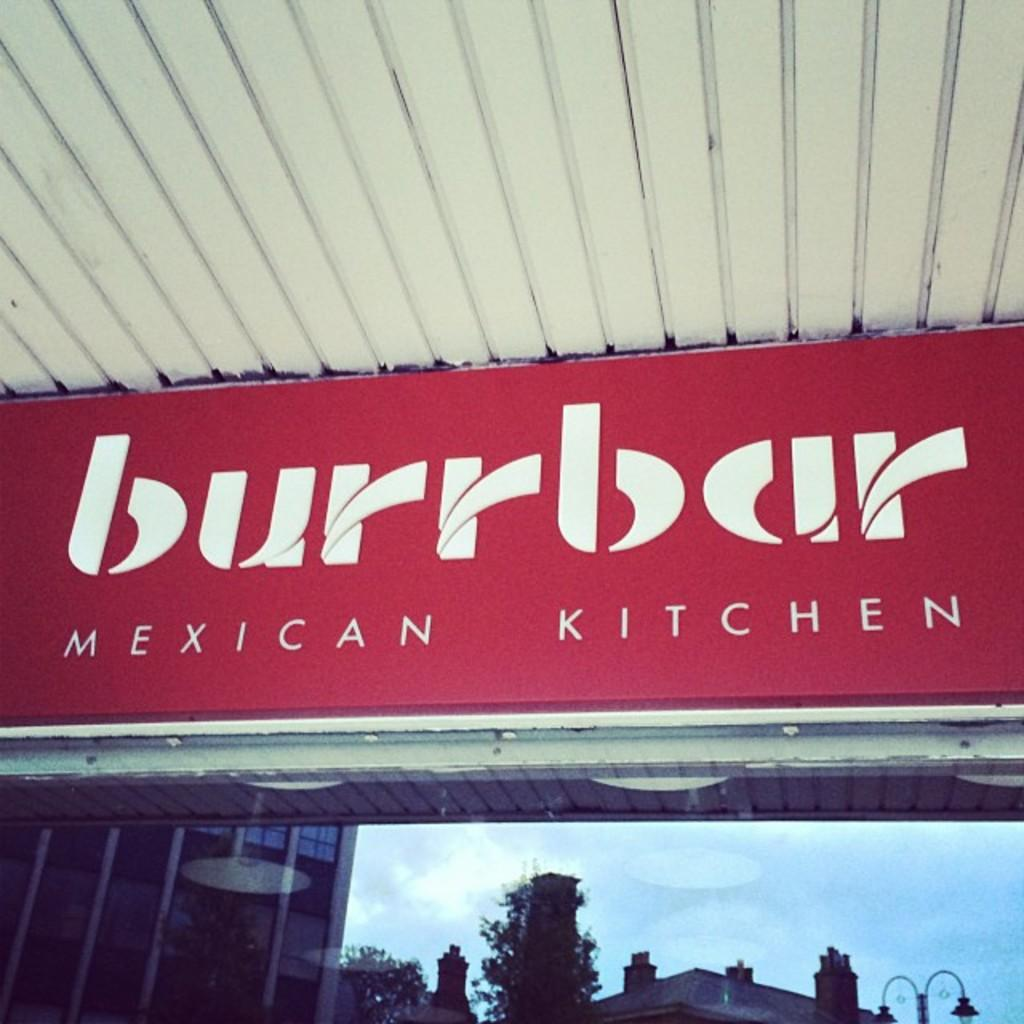Provide a one-sentence caption for the provided image. A red and white sign for Burrbar Mexican Kitchen. 